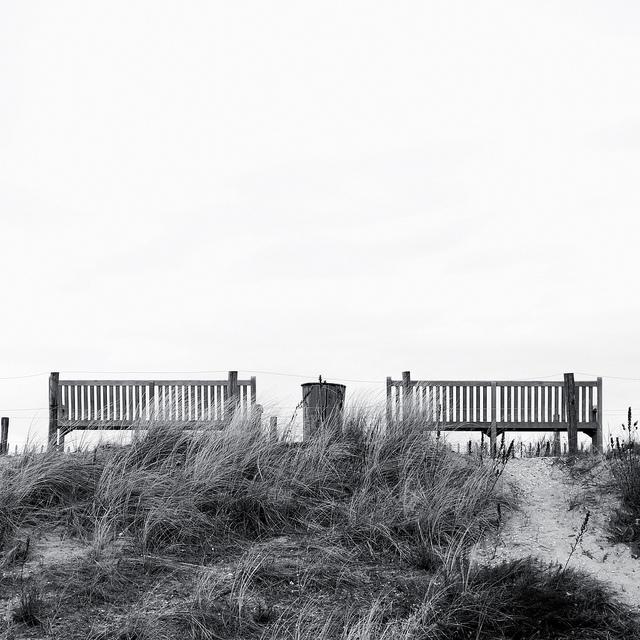Where is the trash container?
Quick response, please. Between benches. What number of benches are in this image?
Concise answer only. 2. Where is this picture made?
Be succinct. Beach. 